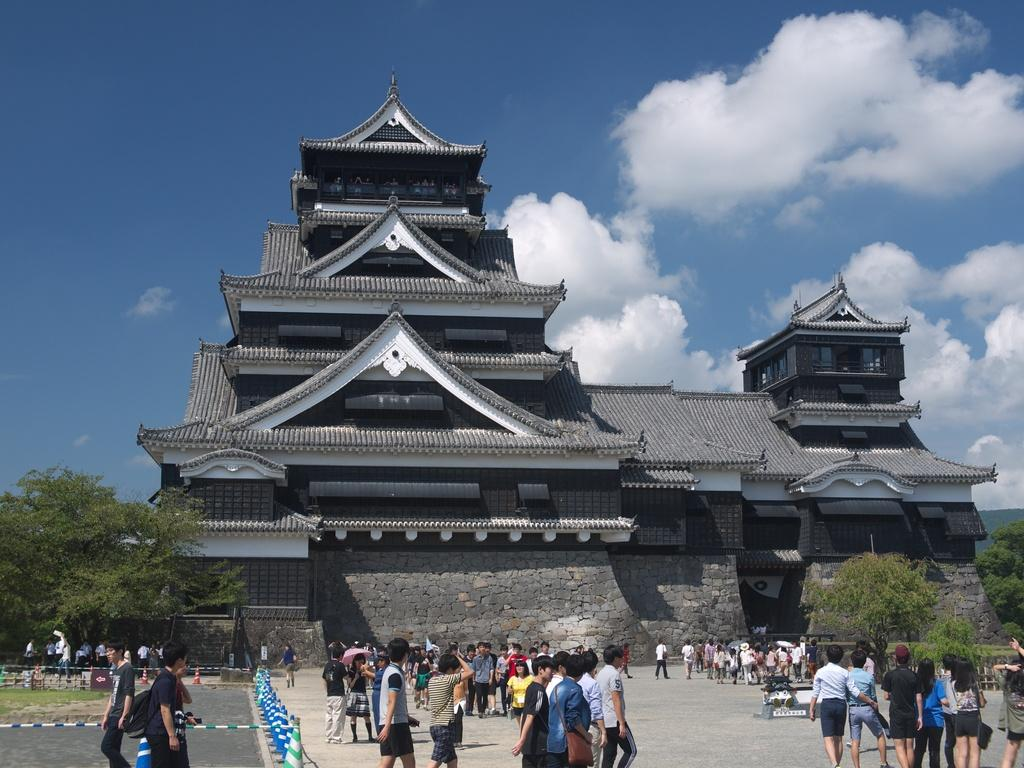Who or what is present in the image? There are people in the image. What type of natural elements can be seen in the image? There are trees in the image. What type of man-made structure is visible in the image? There is a building in the image. How many stars can be seen in the image? There are no stars visible in the image. What type of clothing item with a zipper can be seen on the people in the image? There is no clothing item with a zipper present in the image. 